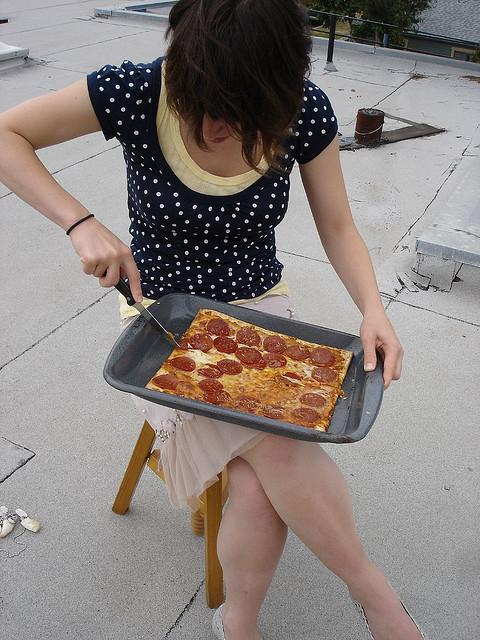What is different about this pizza than most pizzas? square 